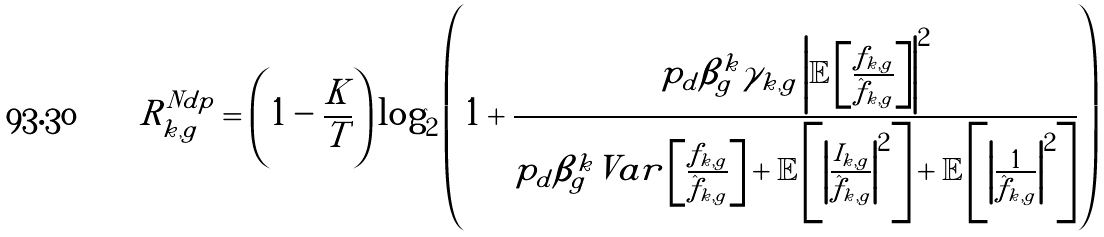<formula> <loc_0><loc_0><loc_500><loc_500>R _ { k , g } ^ { N d p } = \left ( 1 - \frac { K } { T } \right ) \log _ { 2 } \left ( 1 + \frac { p _ { d } \beta _ { g } ^ { k } \gamma _ { k , g } \left | \mathbb { E } \left [ \frac { f _ { k , g } } { \hat { f } _ { k , g } } \right ] \right | ^ { 2 } } { p _ { d } \beta _ { g } ^ { k } V a r \left [ \frac { f _ { k , g } } { \hat { f } _ { k , g } } \right ] + \mathbb { E } \left [ \left | \frac { I _ { k , g } } { \hat { f } _ { k , g } } \right | ^ { 2 } \right ] + \mathbb { E } \left [ \left | \frac { 1 } { \hat { f } _ { k , g } } \right | ^ { 2 } \right ] } \right )</formula> 